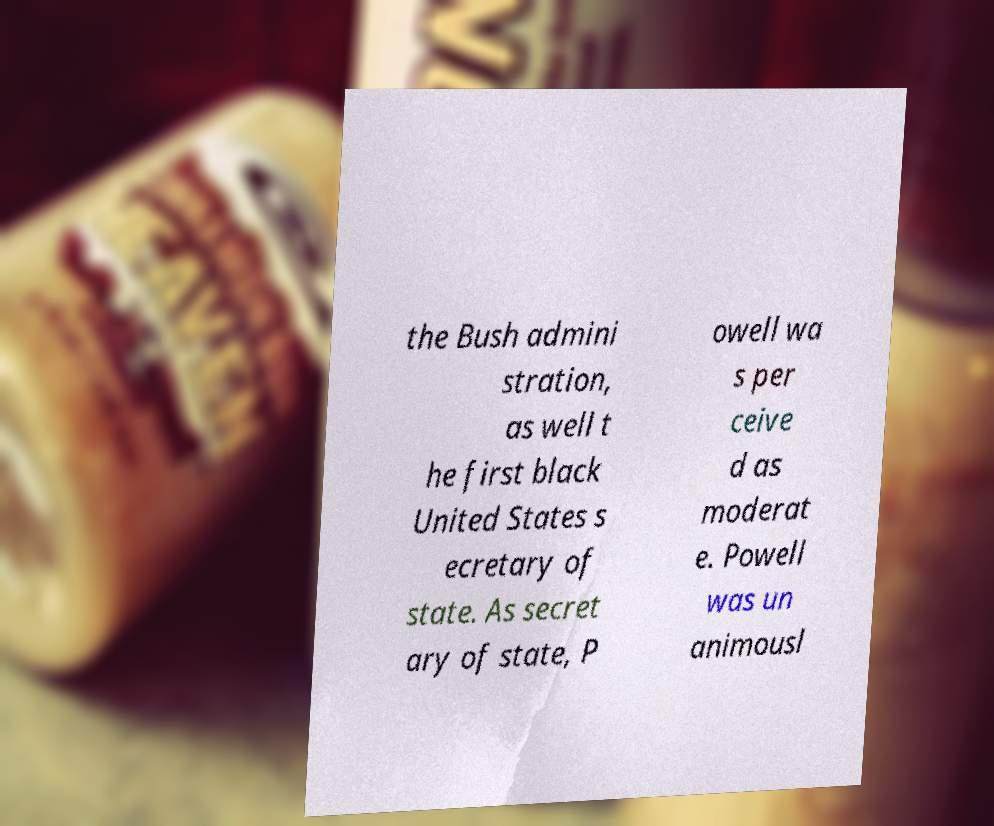Could you extract and type out the text from this image? the Bush admini stration, as well t he first black United States s ecretary of state. As secret ary of state, P owell wa s per ceive d as moderat e. Powell was un animousl 